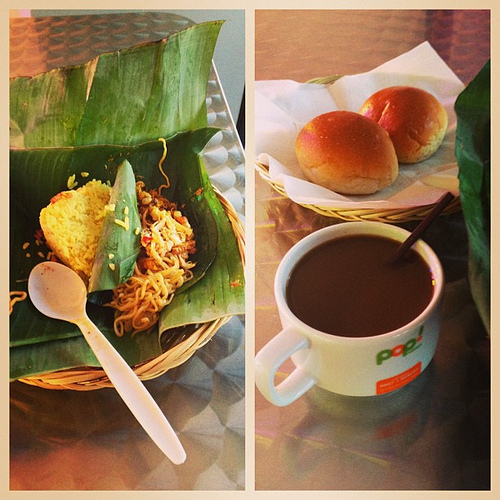What is the straw in? The straw stands casually dipped in a homey mug of coffee, ready to deliver a sip of solace. 